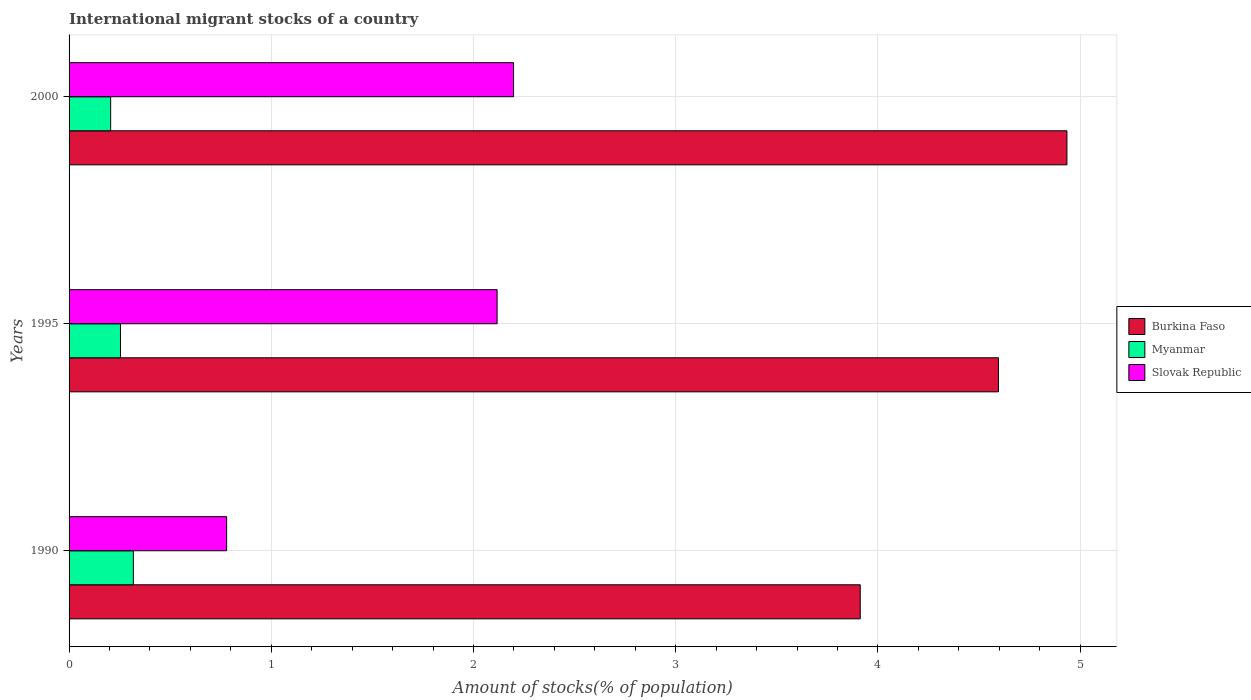Are the number of bars per tick equal to the number of legend labels?
Keep it short and to the point. Yes. Are the number of bars on each tick of the Y-axis equal?
Make the answer very short. Yes. How many bars are there on the 3rd tick from the top?
Your answer should be compact. 3. What is the label of the 2nd group of bars from the top?
Provide a short and direct response. 1995. What is the amount of stocks in in Myanmar in 1990?
Provide a succinct answer. 0.32. Across all years, what is the maximum amount of stocks in in Burkina Faso?
Make the answer very short. 4.93. Across all years, what is the minimum amount of stocks in in Burkina Faso?
Offer a terse response. 3.91. In which year was the amount of stocks in in Burkina Faso minimum?
Give a very brief answer. 1990. What is the total amount of stocks in in Burkina Faso in the graph?
Offer a terse response. 13.44. What is the difference between the amount of stocks in in Myanmar in 1990 and that in 2000?
Keep it short and to the point. 0.11. What is the difference between the amount of stocks in in Slovak Republic in 2000 and the amount of stocks in in Myanmar in 1995?
Your answer should be very brief. 1.94. What is the average amount of stocks in in Burkina Faso per year?
Offer a very short reply. 4.48. In the year 1990, what is the difference between the amount of stocks in in Slovak Republic and amount of stocks in in Burkina Faso?
Your answer should be very brief. -3.13. In how many years, is the amount of stocks in in Slovak Republic greater than 4.4 %?
Offer a terse response. 0. What is the ratio of the amount of stocks in in Burkina Faso in 1990 to that in 1995?
Ensure brevity in your answer.  0.85. What is the difference between the highest and the second highest amount of stocks in in Slovak Republic?
Ensure brevity in your answer.  0.08. What is the difference between the highest and the lowest amount of stocks in in Burkina Faso?
Your answer should be very brief. 1.02. In how many years, is the amount of stocks in in Myanmar greater than the average amount of stocks in in Myanmar taken over all years?
Your answer should be very brief. 1. Is the sum of the amount of stocks in in Burkina Faso in 1990 and 1995 greater than the maximum amount of stocks in in Myanmar across all years?
Your answer should be compact. Yes. What does the 1st bar from the top in 2000 represents?
Offer a terse response. Slovak Republic. What does the 2nd bar from the bottom in 2000 represents?
Provide a short and direct response. Myanmar. Is it the case that in every year, the sum of the amount of stocks in in Myanmar and amount of stocks in in Burkina Faso is greater than the amount of stocks in in Slovak Republic?
Offer a terse response. Yes. How many bars are there?
Keep it short and to the point. 9. Are all the bars in the graph horizontal?
Offer a very short reply. Yes. How many years are there in the graph?
Provide a succinct answer. 3. What is the difference between two consecutive major ticks on the X-axis?
Keep it short and to the point. 1. Are the values on the major ticks of X-axis written in scientific E-notation?
Your response must be concise. No. Does the graph contain grids?
Keep it short and to the point. Yes. Where does the legend appear in the graph?
Offer a terse response. Center right. How many legend labels are there?
Ensure brevity in your answer.  3. How are the legend labels stacked?
Your response must be concise. Vertical. What is the title of the graph?
Offer a terse response. International migrant stocks of a country. What is the label or title of the X-axis?
Provide a succinct answer. Amount of stocks(% of population). What is the Amount of stocks(% of population) of Burkina Faso in 1990?
Your response must be concise. 3.91. What is the Amount of stocks(% of population) of Myanmar in 1990?
Your response must be concise. 0.32. What is the Amount of stocks(% of population) of Slovak Republic in 1990?
Give a very brief answer. 0.78. What is the Amount of stocks(% of population) in Burkina Faso in 1995?
Give a very brief answer. 4.6. What is the Amount of stocks(% of population) in Myanmar in 1995?
Keep it short and to the point. 0.25. What is the Amount of stocks(% of population) in Slovak Republic in 1995?
Give a very brief answer. 2.12. What is the Amount of stocks(% of population) of Burkina Faso in 2000?
Provide a short and direct response. 4.93. What is the Amount of stocks(% of population) in Myanmar in 2000?
Ensure brevity in your answer.  0.21. What is the Amount of stocks(% of population) in Slovak Republic in 2000?
Offer a terse response. 2.2. Across all years, what is the maximum Amount of stocks(% of population) in Burkina Faso?
Offer a very short reply. 4.93. Across all years, what is the maximum Amount of stocks(% of population) in Myanmar?
Offer a very short reply. 0.32. Across all years, what is the maximum Amount of stocks(% of population) in Slovak Republic?
Provide a succinct answer. 2.2. Across all years, what is the minimum Amount of stocks(% of population) of Burkina Faso?
Give a very brief answer. 3.91. Across all years, what is the minimum Amount of stocks(% of population) in Myanmar?
Give a very brief answer. 0.21. Across all years, what is the minimum Amount of stocks(% of population) of Slovak Republic?
Give a very brief answer. 0.78. What is the total Amount of stocks(% of population) of Burkina Faso in the graph?
Provide a short and direct response. 13.44. What is the total Amount of stocks(% of population) of Myanmar in the graph?
Keep it short and to the point. 0.78. What is the total Amount of stocks(% of population) in Slovak Republic in the graph?
Your response must be concise. 5.09. What is the difference between the Amount of stocks(% of population) of Burkina Faso in 1990 and that in 1995?
Keep it short and to the point. -0.68. What is the difference between the Amount of stocks(% of population) in Myanmar in 1990 and that in 1995?
Offer a very short reply. 0.06. What is the difference between the Amount of stocks(% of population) in Slovak Republic in 1990 and that in 1995?
Give a very brief answer. -1.34. What is the difference between the Amount of stocks(% of population) of Burkina Faso in 1990 and that in 2000?
Offer a very short reply. -1.02. What is the difference between the Amount of stocks(% of population) of Myanmar in 1990 and that in 2000?
Make the answer very short. 0.11. What is the difference between the Amount of stocks(% of population) of Slovak Republic in 1990 and that in 2000?
Provide a short and direct response. -1.42. What is the difference between the Amount of stocks(% of population) in Burkina Faso in 1995 and that in 2000?
Give a very brief answer. -0.34. What is the difference between the Amount of stocks(% of population) of Myanmar in 1995 and that in 2000?
Offer a terse response. 0.05. What is the difference between the Amount of stocks(% of population) of Slovak Republic in 1995 and that in 2000?
Your answer should be compact. -0.08. What is the difference between the Amount of stocks(% of population) in Burkina Faso in 1990 and the Amount of stocks(% of population) in Myanmar in 1995?
Your answer should be very brief. 3.66. What is the difference between the Amount of stocks(% of population) of Burkina Faso in 1990 and the Amount of stocks(% of population) of Slovak Republic in 1995?
Your answer should be compact. 1.8. What is the difference between the Amount of stocks(% of population) in Myanmar in 1990 and the Amount of stocks(% of population) in Slovak Republic in 1995?
Give a very brief answer. -1.8. What is the difference between the Amount of stocks(% of population) in Burkina Faso in 1990 and the Amount of stocks(% of population) in Myanmar in 2000?
Your response must be concise. 3.71. What is the difference between the Amount of stocks(% of population) of Burkina Faso in 1990 and the Amount of stocks(% of population) of Slovak Republic in 2000?
Your answer should be very brief. 1.71. What is the difference between the Amount of stocks(% of population) in Myanmar in 1990 and the Amount of stocks(% of population) in Slovak Republic in 2000?
Provide a short and direct response. -1.88. What is the difference between the Amount of stocks(% of population) in Burkina Faso in 1995 and the Amount of stocks(% of population) in Myanmar in 2000?
Provide a short and direct response. 4.39. What is the difference between the Amount of stocks(% of population) in Burkina Faso in 1995 and the Amount of stocks(% of population) in Slovak Republic in 2000?
Give a very brief answer. 2.4. What is the difference between the Amount of stocks(% of population) in Myanmar in 1995 and the Amount of stocks(% of population) in Slovak Republic in 2000?
Provide a short and direct response. -1.94. What is the average Amount of stocks(% of population) in Burkina Faso per year?
Your answer should be very brief. 4.48. What is the average Amount of stocks(% of population) of Myanmar per year?
Make the answer very short. 0.26. What is the average Amount of stocks(% of population) of Slovak Republic per year?
Offer a very short reply. 1.7. In the year 1990, what is the difference between the Amount of stocks(% of population) of Burkina Faso and Amount of stocks(% of population) of Myanmar?
Provide a short and direct response. 3.59. In the year 1990, what is the difference between the Amount of stocks(% of population) of Burkina Faso and Amount of stocks(% of population) of Slovak Republic?
Keep it short and to the point. 3.13. In the year 1990, what is the difference between the Amount of stocks(% of population) in Myanmar and Amount of stocks(% of population) in Slovak Republic?
Make the answer very short. -0.46. In the year 1995, what is the difference between the Amount of stocks(% of population) of Burkina Faso and Amount of stocks(% of population) of Myanmar?
Keep it short and to the point. 4.34. In the year 1995, what is the difference between the Amount of stocks(% of population) in Burkina Faso and Amount of stocks(% of population) in Slovak Republic?
Your response must be concise. 2.48. In the year 1995, what is the difference between the Amount of stocks(% of population) in Myanmar and Amount of stocks(% of population) in Slovak Republic?
Offer a very short reply. -1.86. In the year 2000, what is the difference between the Amount of stocks(% of population) in Burkina Faso and Amount of stocks(% of population) in Myanmar?
Make the answer very short. 4.73. In the year 2000, what is the difference between the Amount of stocks(% of population) of Burkina Faso and Amount of stocks(% of population) of Slovak Republic?
Your response must be concise. 2.74. In the year 2000, what is the difference between the Amount of stocks(% of population) in Myanmar and Amount of stocks(% of population) in Slovak Republic?
Your response must be concise. -1.99. What is the ratio of the Amount of stocks(% of population) in Burkina Faso in 1990 to that in 1995?
Offer a terse response. 0.85. What is the ratio of the Amount of stocks(% of population) of Myanmar in 1990 to that in 1995?
Your answer should be compact. 1.25. What is the ratio of the Amount of stocks(% of population) in Slovak Republic in 1990 to that in 1995?
Offer a terse response. 0.37. What is the ratio of the Amount of stocks(% of population) in Burkina Faso in 1990 to that in 2000?
Give a very brief answer. 0.79. What is the ratio of the Amount of stocks(% of population) of Myanmar in 1990 to that in 2000?
Your answer should be compact. 1.55. What is the ratio of the Amount of stocks(% of population) in Slovak Republic in 1990 to that in 2000?
Keep it short and to the point. 0.35. What is the ratio of the Amount of stocks(% of population) in Burkina Faso in 1995 to that in 2000?
Provide a short and direct response. 0.93. What is the ratio of the Amount of stocks(% of population) of Myanmar in 1995 to that in 2000?
Give a very brief answer. 1.24. What is the ratio of the Amount of stocks(% of population) in Slovak Republic in 1995 to that in 2000?
Your answer should be very brief. 0.96. What is the difference between the highest and the second highest Amount of stocks(% of population) of Burkina Faso?
Offer a terse response. 0.34. What is the difference between the highest and the second highest Amount of stocks(% of population) of Myanmar?
Your answer should be very brief. 0.06. What is the difference between the highest and the second highest Amount of stocks(% of population) in Slovak Republic?
Ensure brevity in your answer.  0.08. What is the difference between the highest and the lowest Amount of stocks(% of population) of Burkina Faso?
Make the answer very short. 1.02. What is the difference between the highest and the lowest Amount of stocks(% of population) in Myanmar?
Offer a very short reply. 0.11. What is the difference between the highest and the lowest Amount of stocks(% of population) in Slovak Republic?
Offer a terse response. 1.42. 